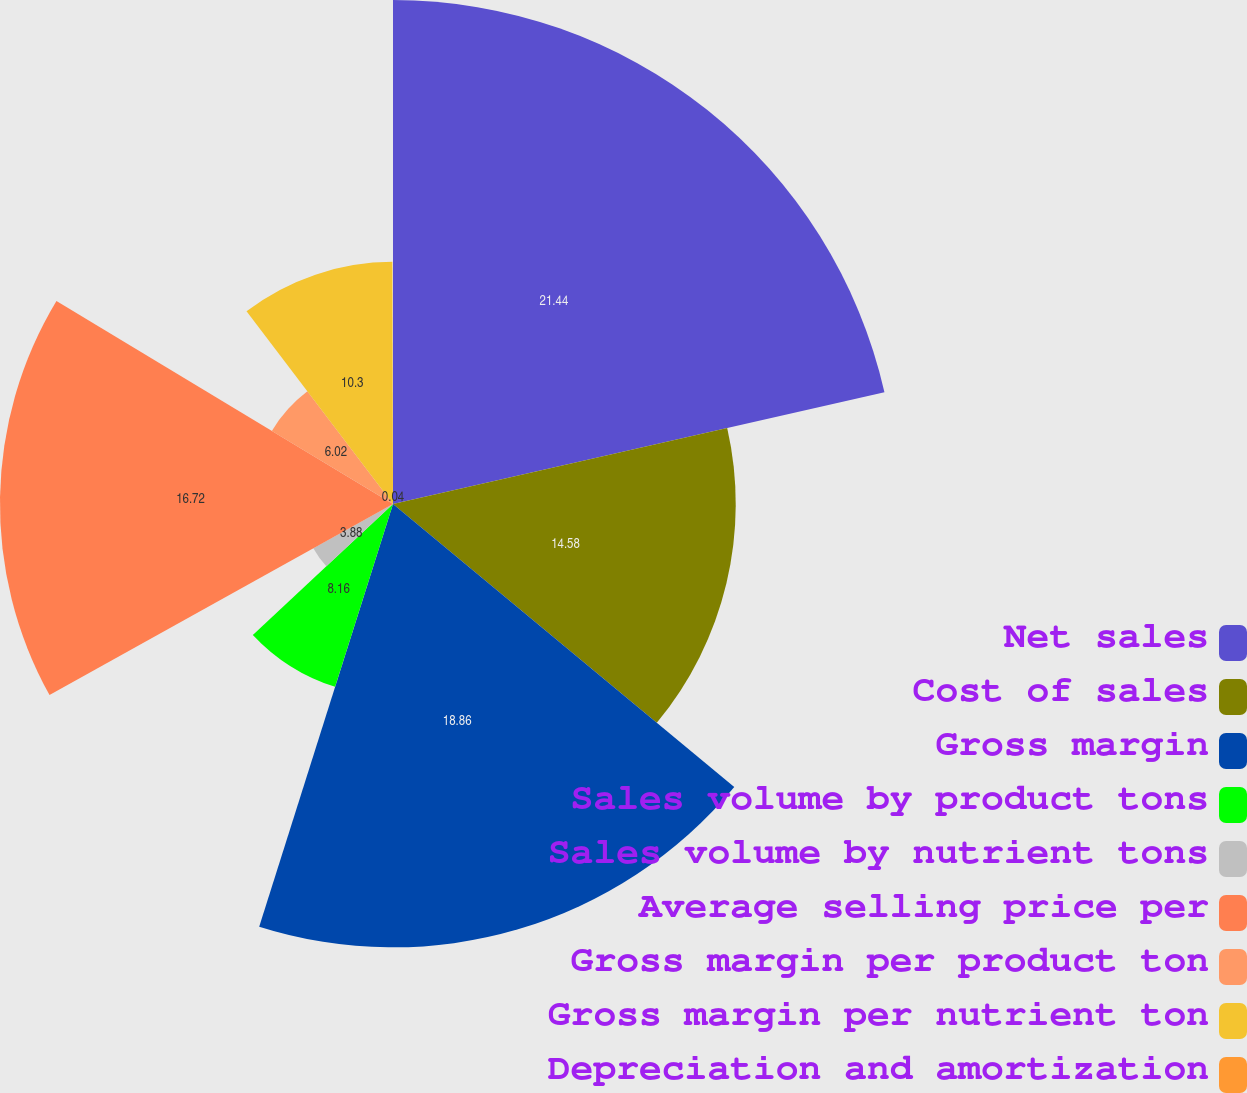Convert chart. <chart><loc_0><loc_0><loc_500><loc_500><pie_chart><fcel>Net sales<fcel>Cost of sales<fcel>Gross margin<fcel>Sales volume by product tons<fcel>Sales volume by nutrient tons<fcel>Average selling price per<fcel>Gross margin per product ton<fcel>Gross margin per nutrient ton<fcel>Depreciation and amortization<nl><fcel>21.44%<fcel>14.58%<fcel>18.86%<fcel>8.16%<fcel>3.88%<fcel>16.72%<fcel>6.02%<fcel>10.3%<fcel>0.04%<nl></chart> 